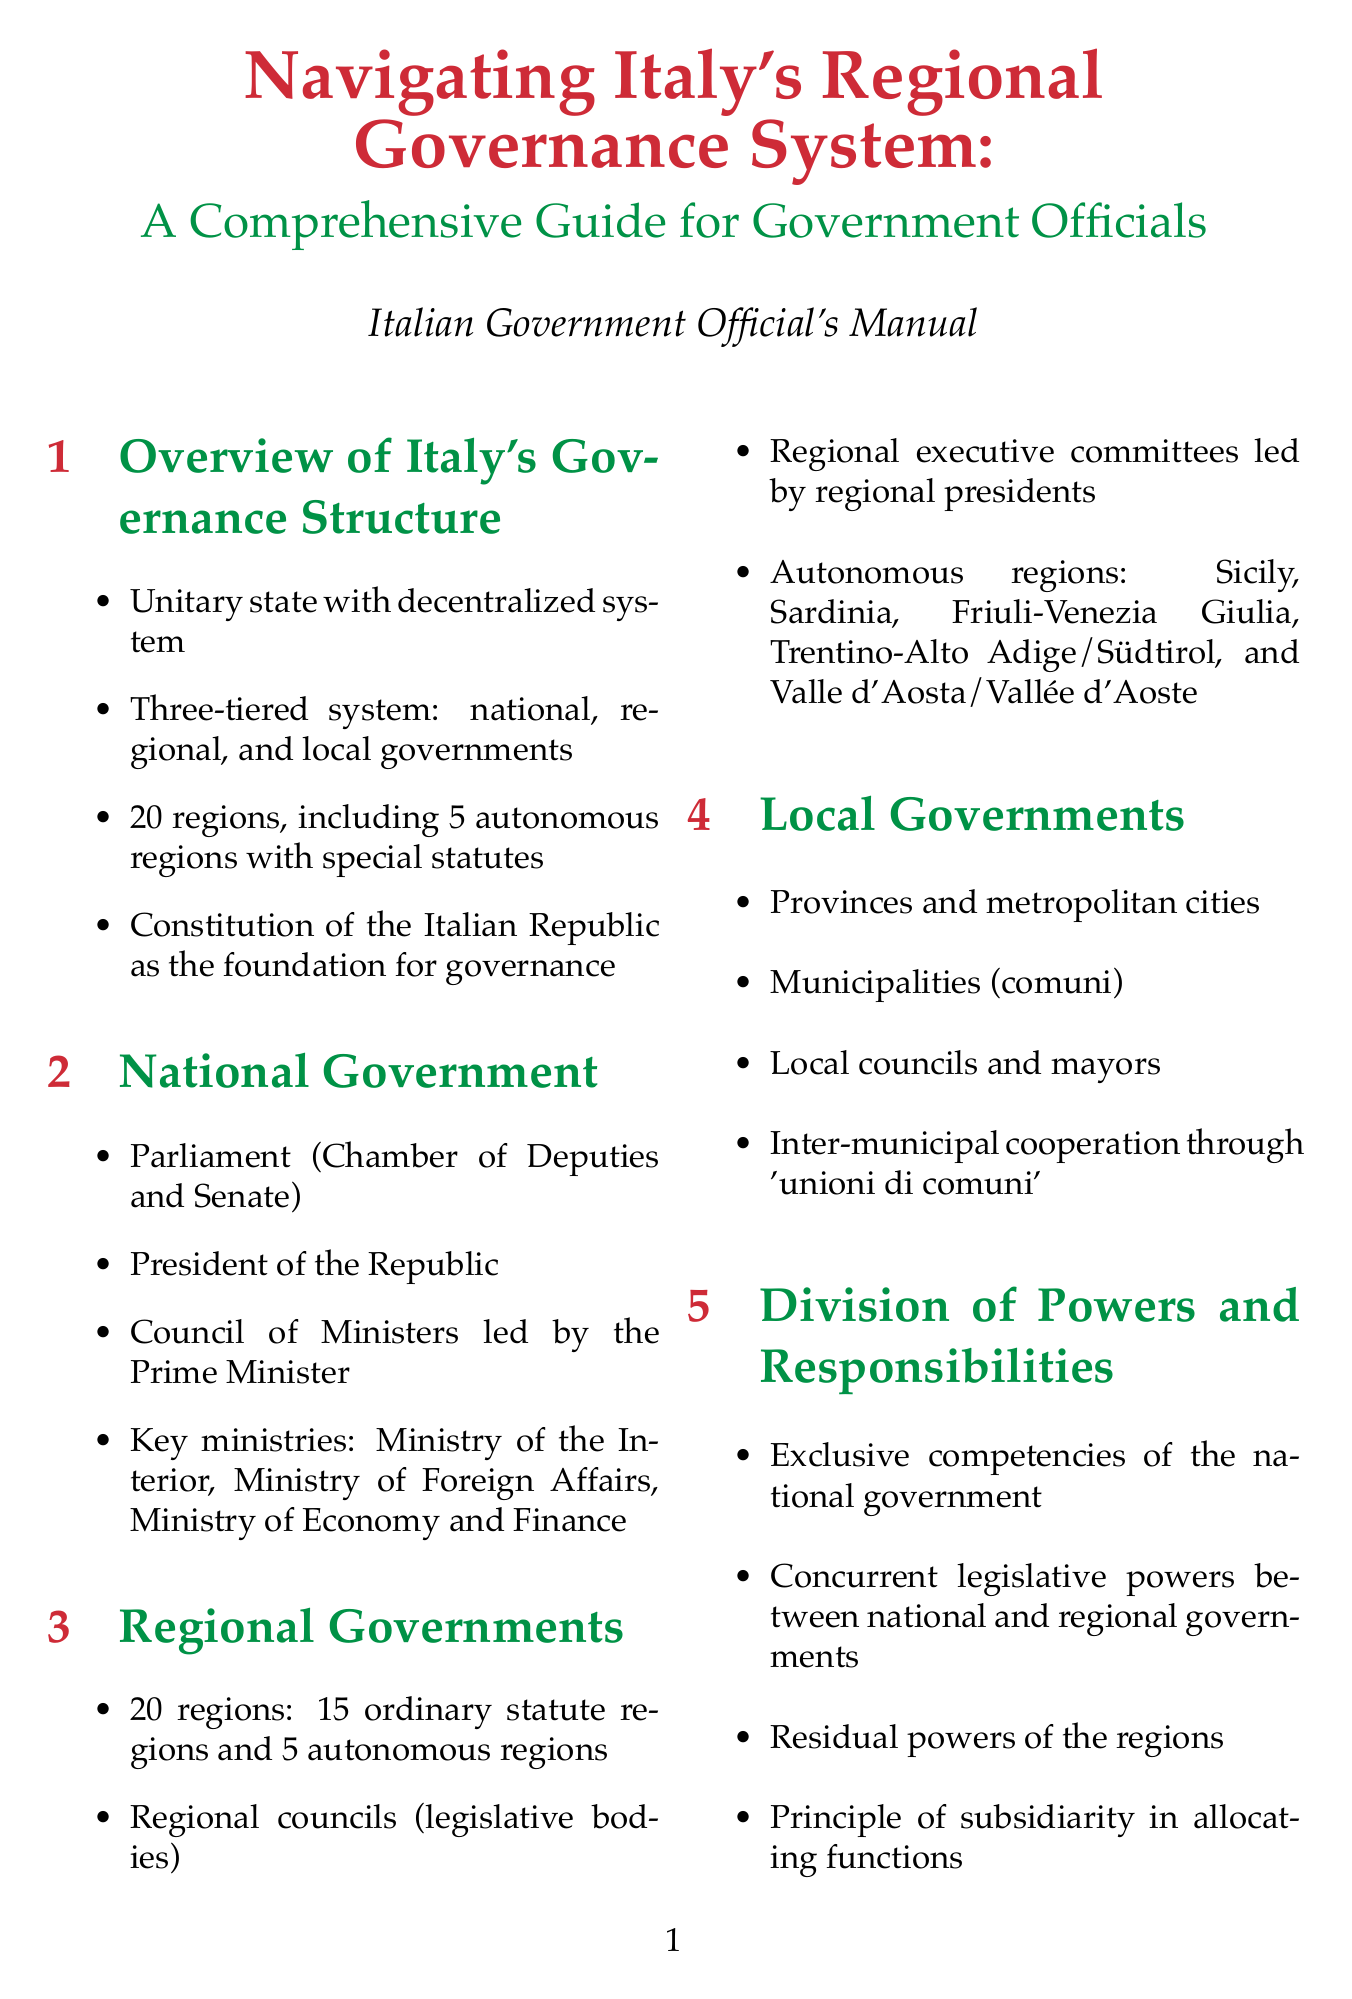What is the title of the manual? The title of the manual is found at the beginning, presenting the comprehensive nature of the guide for government officials.
Answer: Navigating Italy's Regional Governance System: A Comprehensive Guide for Government Officials How many regions are there in Italy? The number of regions is stated clearly in the overview section, listing both ordinary and autonomous regions.
Answer: 20 regions What are the names of the autonomous regions? The autonomous regions are specifically mentioned in the section about regional governments, identifying each by name.
Answer: Sicily, Sardinia, Friuli-Venezia Giulia, Trentino-Alto Adige/Südtirol, Valle d'Aosta/Vallée d'Aoste What is the principle guiding the division of powers? The principle is explicitly noted in the division of powers section, highlighting its importance in governance.
Answer: Principle of subsidiarity Which key competency involves economic development? The key competencies section lists specific areas of responsibility for regional governments, including this particular area.
Answer: Economic development and tourism What is the purpose of the Equalization fund? The purpose of the Equalization fund is mentioned in the fiscal federalism section, describing its role in supporting regions.
Answer: For less developed regions What ongoing debate is mentioned regarding regional governance? The challenges and reforms section highlights this particular topic, indicating current discussions in governance.
Answer: Further devolution of powers Which document provides the foundation for governance? This foundational document is explicitly mentioned in the overview section, establishing its significance.
Answer: Constitution of the Italian Republic What type of cooperation is fostered among municipalities? The local governments section introduces this cooperative form to highlight its importance in governance.
Answer: Unioni di comuni 